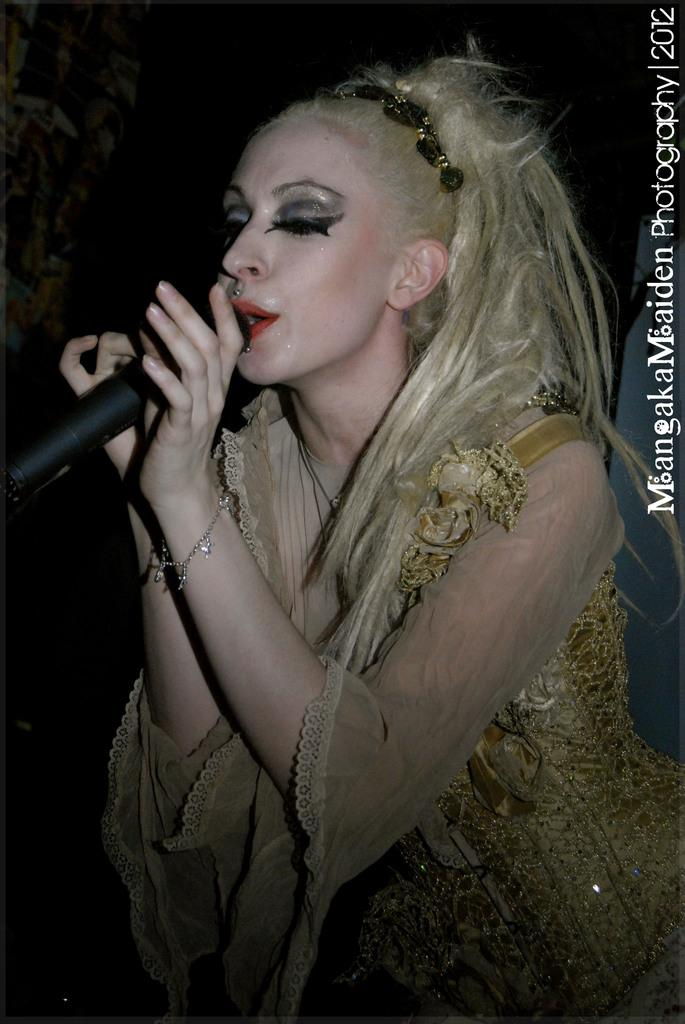What is the woman in the image doing? The woman is singing in the image. What is the woman holding in her hand? The woman is holding a microphone in her hand. What accessories is the woman wearing? The woman is wearing a hairband and a bracelet. What type of clothing is the woman wearing? The woman is wearing a nice dress. What type of brass instrument is the woman playing in the image? There is no brass instrument present in the image; the woman is holding a microphone and singing. How much income does the woman earn from her performance in the image? The image does not provide information about the woman's income or any financial aspect of her performance. 